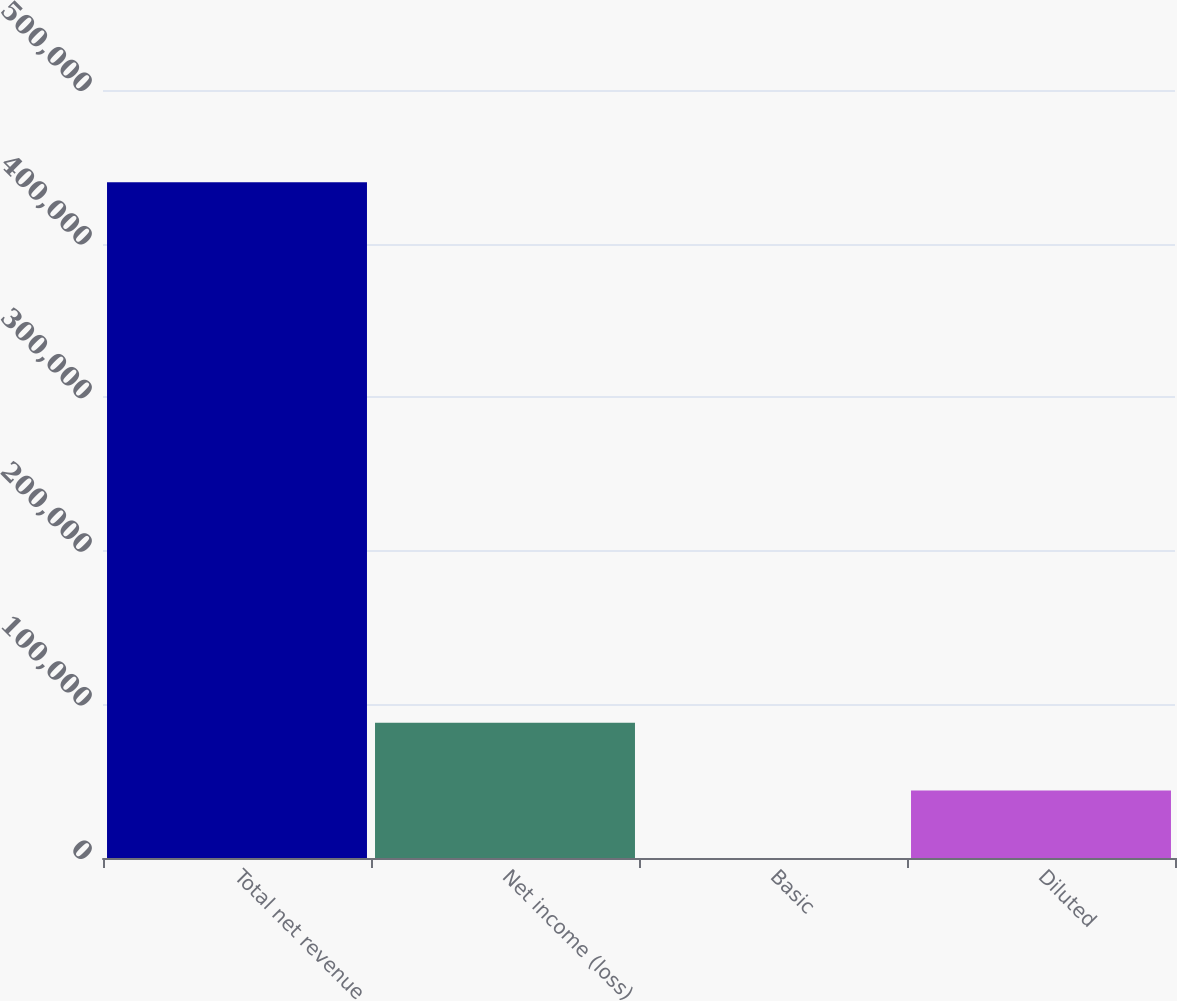<chart> <loc_0><loc_0><loc_500><loc_500><bar_chart><fcel>Total net revenue<fcel>Net income (loss)<fcel>Basic<fcel>Diluted<nl><fcel>439931<fcel>87986.4<fcel>0.19<fcel>43993.3<nl></chart> 